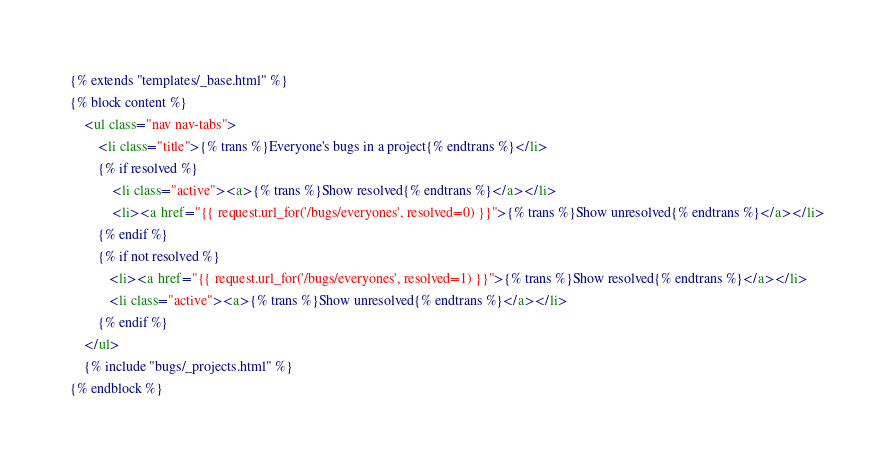<code> <loc_0><loc_0><loc_500><loc_500><_HTML_>{% extends "templates/_base.html" %}
{% block content %}
    <ul class="nav nav-tabs">
        <li class="title">{% trans %}Everyone's bugs in a project{% endtrans %}</li>
        {% if resolved %}
            <li class="active"><a>{% trans %}Show resolved{% endtrans %}</a></li>
            <li><a href="{{ request.url_for('/bugs/everyones', resolved=0) }}">{% trans %}Show unresolved{% endtrans %}</a></li>
        {% endif %}        
        {% if not resolved %}
           <li><a href="{{ request.url_for('/bugs/everyones', resolved=1) }}">{% trans %}Show resolved{% endtrans %}</a></li>
           <li class="active"><a>{% trans %}Show unresolved{% endtrans %}</a></li>
        {% endif %}
    </ul>
    {% include "bugs/_projects.html" %}
{% endblock %}
</code> 